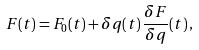Convert formula to latex. <formula><loc_0><loc_0><loc_500><loc_500>F ( t ) = F _ { 0 } ( t ) + \delta q ( t ) \, \frac { \delta F } { \delta q } ( t ) \, ,</formula> 